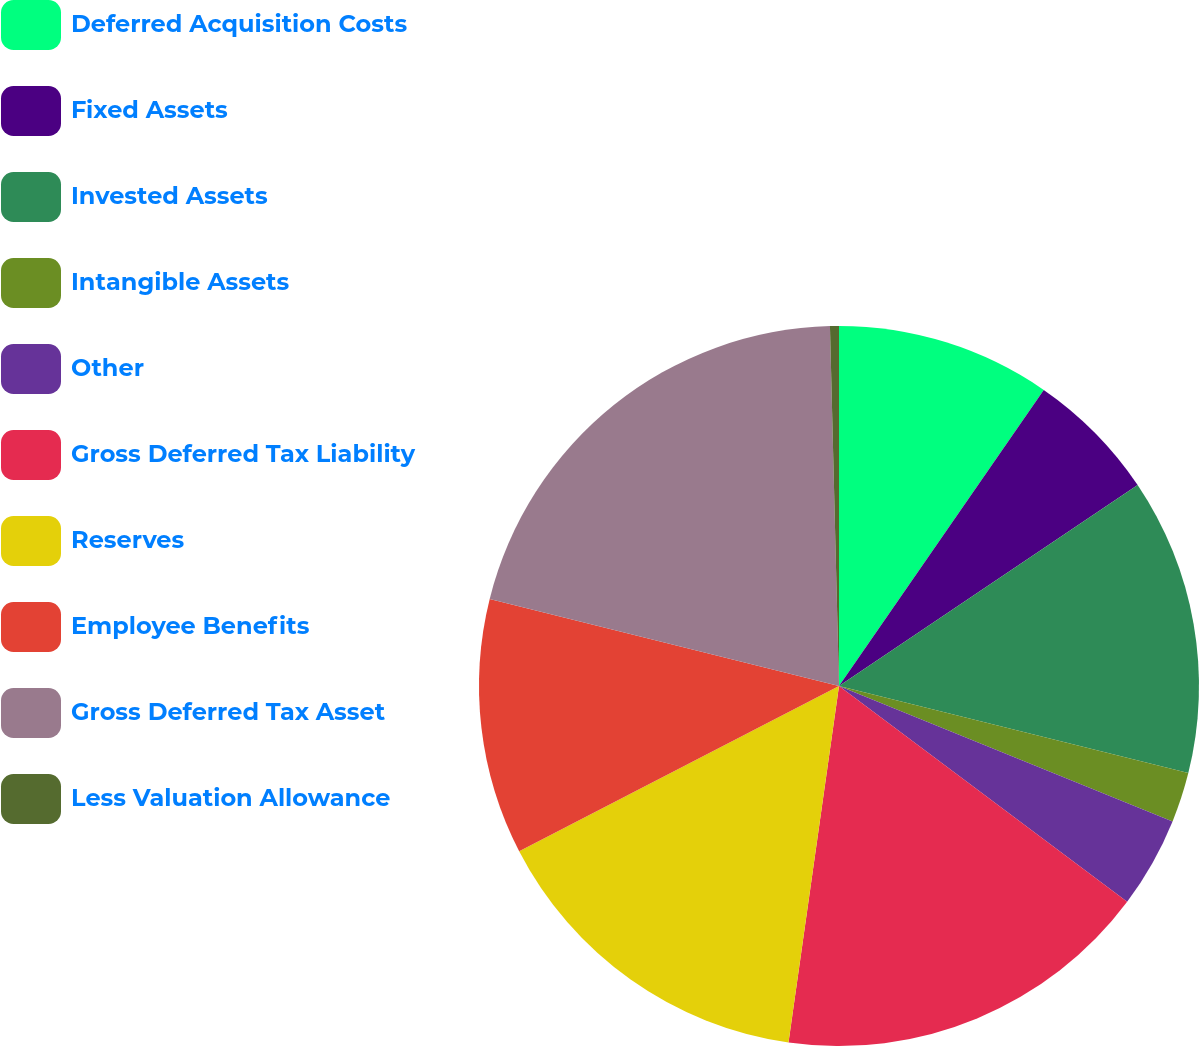<chart> <loc_0><loc_0><loc_500><loc_500><pie_chart><fcel>Deferred Acquisition Costs<fcel>Fixed Assets<fcel>Invested Assets<fcel>Intangible Assets<fcel>Other<fcel>Gross Deferred Tax Liability<fcel>Reserves<fcel>Employee Benefits<fcel>Gross Deferred Tax Asset<fcel>Less Valuation Allowance<nl><fcel>9.63%<fcel>5.94%<fcel>13.32%<fcel>2.25%<fcel>4.09%<fcel>17.01%<fcel>15.17%<fcel>11.48%<fcel>20.71%<fcel>0.4%<nl></chart> 